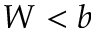<formula> <loc_0><loc_0><loc_500><loc_500>W < b</formula> 